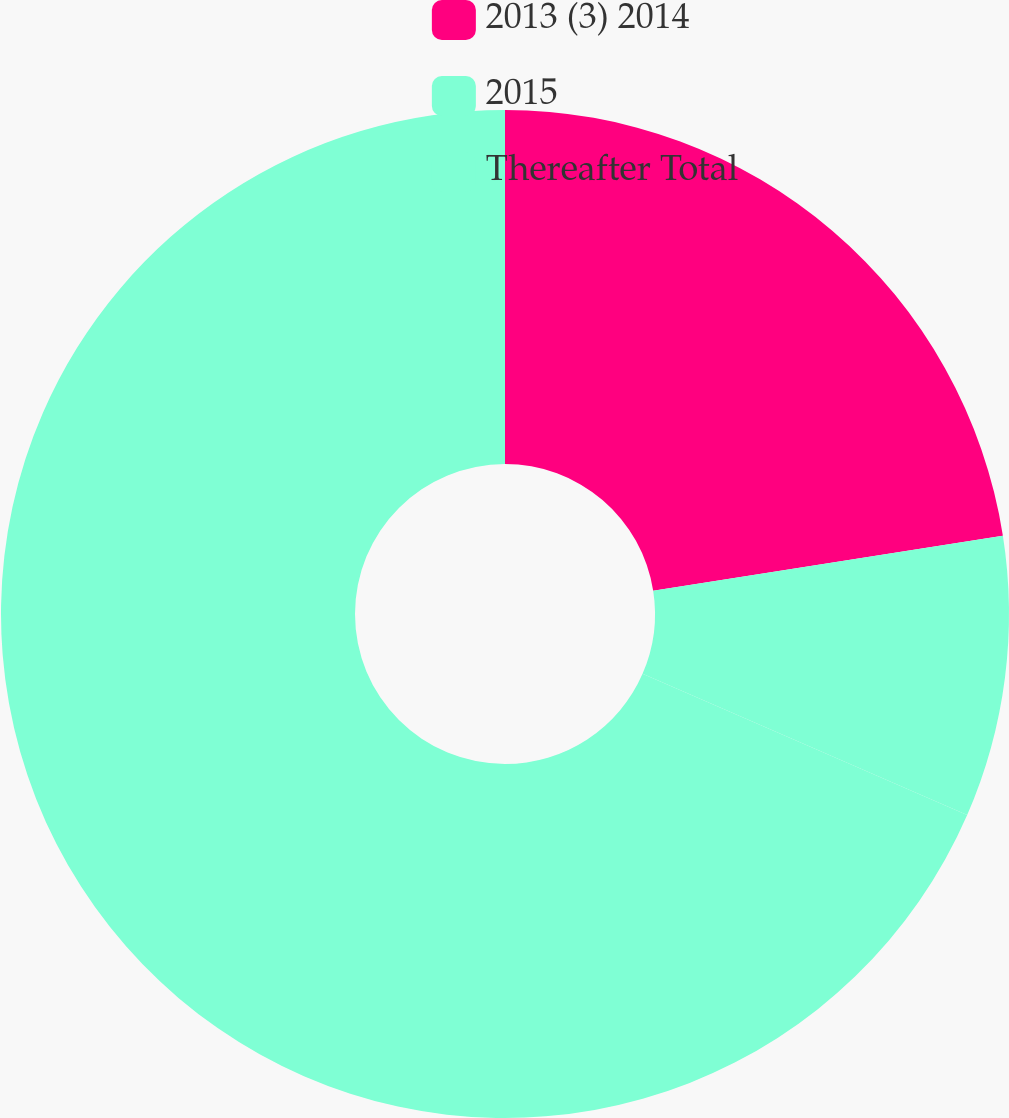<chart> <loc_0><loc_0><loc_500><loc_500><pie_chart><fcel>2013 (3) 2014<fcel>2015<fcel>Thereafter Total<nl><fcel>22.52%<fcel>9.01%<fcel>68.47%<nl></chart> 